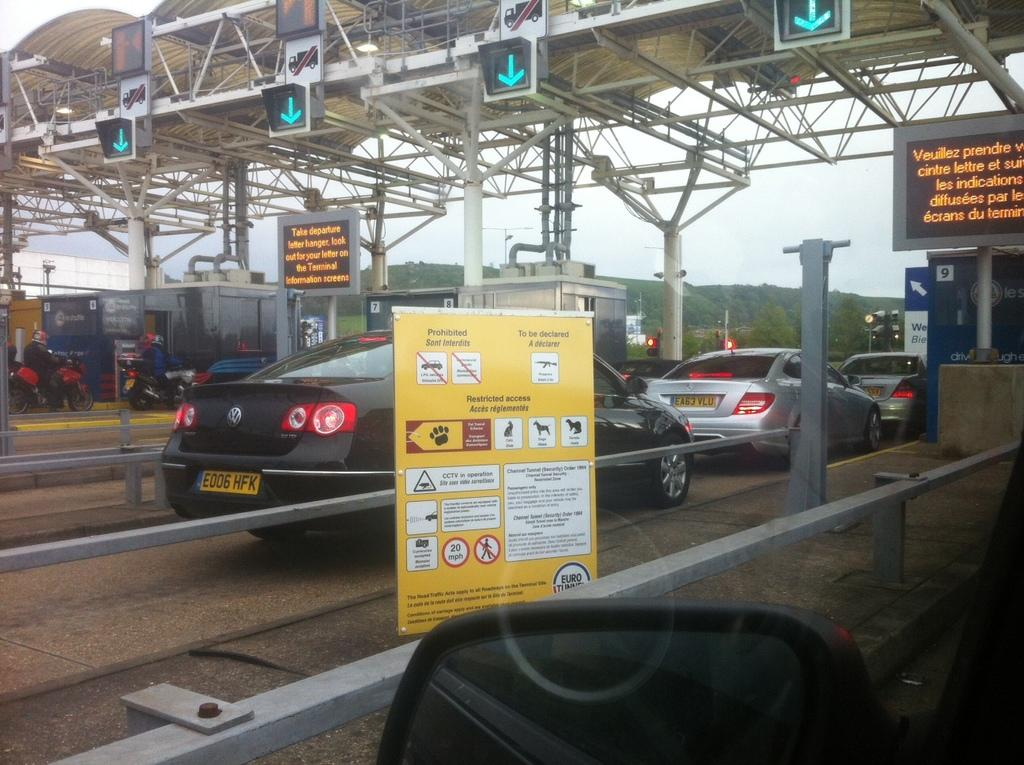<image>
Render a clear and concise summary of the photo. a license plate that has the number E006 on it 